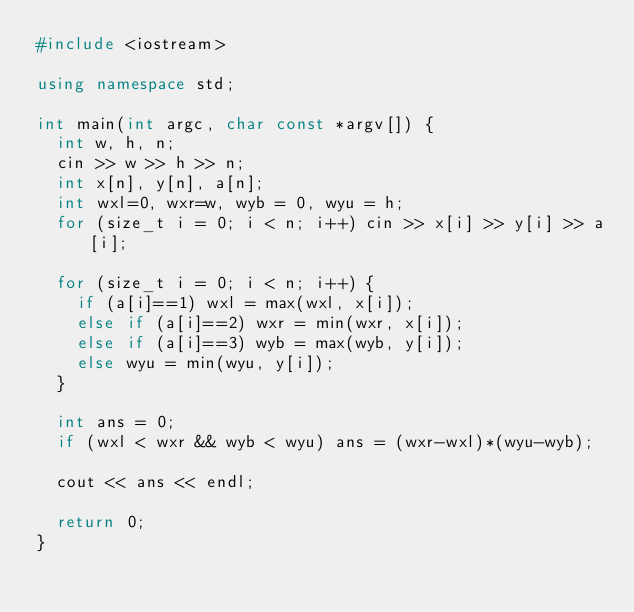<code> <loc_0><loc_0><loc_500><loc_500><_C++_>#include <iostream>

using namespace std;

int main(int argc, char const *argv[]) {
  int w, h, n;
  cin >> w >> h >> n;
  int x[n], y[n], a[n];
  int wxl=0, wxr=w, wyb = 0, wyu = h;
  for (size_t i = 0; i < n; i++) cin >> x[i] >> y[i] >> a[i];

  for (size_t i = 0; i < n; i++) {
    if (a[i]==1) wxl = max(wxl, x[i]);
    else if (a[i]==2) wxr = min(wxr, x[i]);
    else if (a[i]==3) wyb = max(wyb, y[i]);
    else wyu = min(wyu, y[i]);
  }

  int ans = 0;
  if (wxl < wxr && wyb < wyu) ans = (wxr-wxl)*(wyu-wyb);

  cout << ans << endl;

  return 0;
}
</code> 